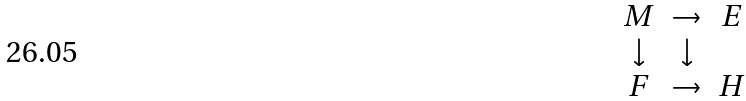<formula> <loc_0><loc_0><loc_500><loc_500>\begin{matrix} M & \rightarrow & E \\ \downarrow & \downarrow \\ F & \rightarrow & H \end{matrix}</formula> 